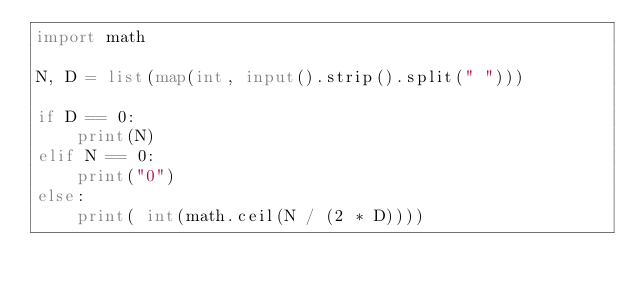<code> <loc_0><loc_0><loc_500><loc_500><_Python_>import math
 
N, D = list(map(int, input().strip().split(" ")))

if D == 0:
    print(N)
elif N == 0:
    print("0")
else:
	print( int(math.ceil(N / (2 * D))))</code> 